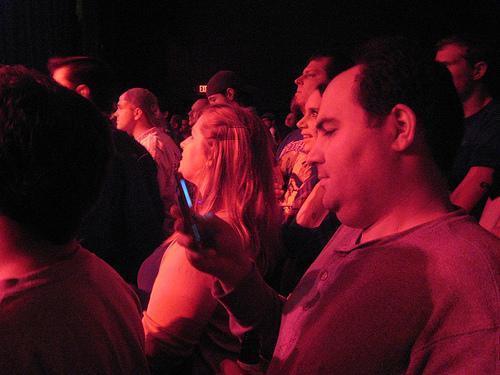How many men have hats on?
Give a very brief answer. 2. 